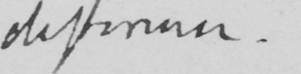What text is written in this handwritten line? difference.] 